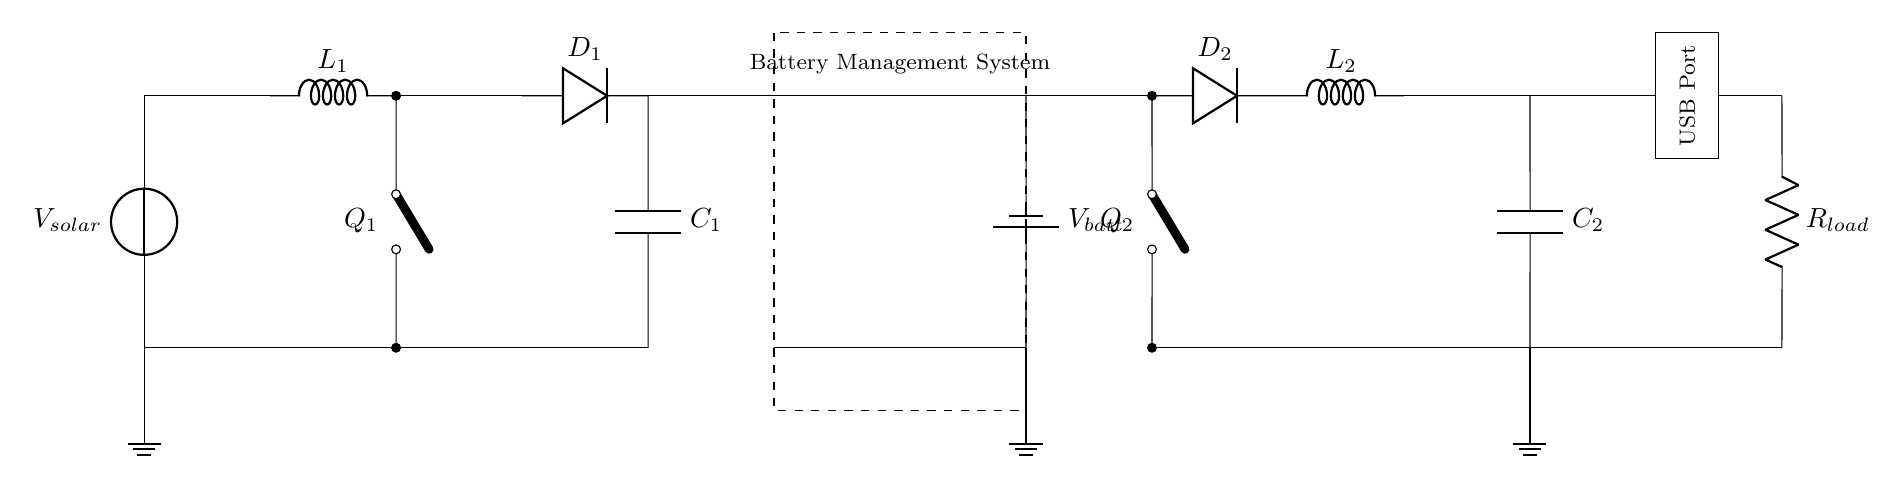What is the function of the solar panel in this circuit? The solar panel converts sunlight into electrical energy, providing the initial voltage source for the circuit.
Answer: generates electricity What is the role of the switch Q1? The switch Q1 controls the flow of current through the inductor L1, allowing the boost converter to operate by periodically connecting and disconnecting the inductor from the circuit.
Answer: connects L1 What does the battery management system do? The battery management system oversees charge and discharge processes, maintaining battery health and safety by preventing overcharging or deep discharging.
Answer: manages battery How many capacitors are in the circuit? There are two capacitors shown in the circuit diagram, C1 and C2.
Answer: two capacitors What type of output does this circuit provide? The circuit provides a USB output for charging portable devices, allowing them to draw power from the circuit.
Answer: USB output What happens when switch Q2 is opened? When switch Q2 is opened, the load connected to the USB port is disconnected, preventing any current from flowing to the load, effectively turning it off.
Answer: load off What is the purpose of the inductor L1? The inductor L1 stores energy when the switch Q1 is closed and releases it when the switch is opened, helping to step up the voltage for efficient charging.
Answer: boosts voltage 